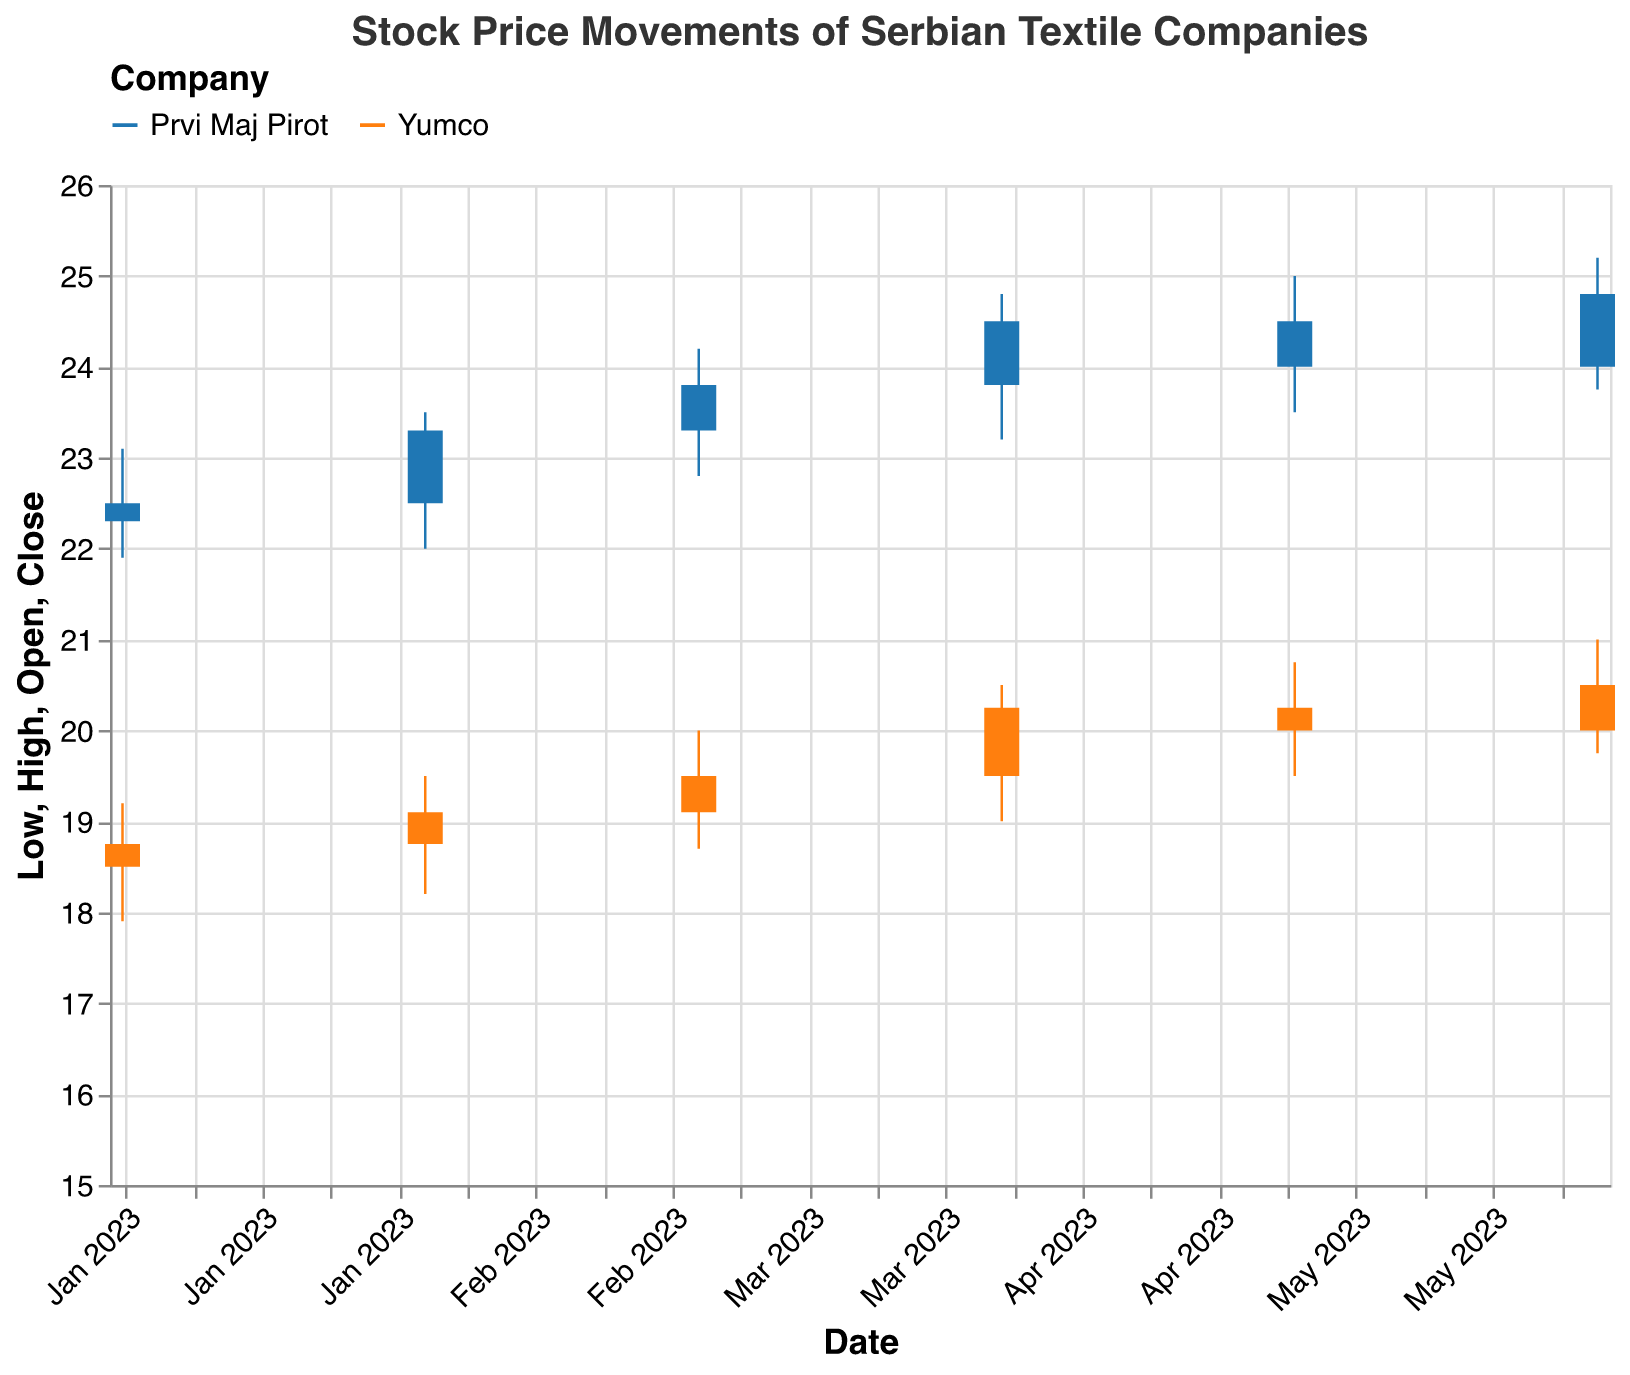What is the title of the plot? The title is usually placed at the top of the figure and gives an overview of what the data represents. Here, the title of the plot is "Stock Price Movements of Serbian Textile Companies".
Answer: Stock Price Movements of Serbian Textile Companies How many data points are there for Yumco? By looking at the x-axis and filtering data visually for the company named "Yumco," we can count the number of distinct dates or candlesticks in the plot. There are 6 data points corresponding to Yumco from January to June 2023.
Answer: 6 Which company had the highest closing price in June 2023? Check the candlestick for June 2023 for both companies. Yumco's closing price is 20.50, and Prvi Maj Pirot's closing price is 24.80. Prvi Maj Pirot has the higher closing price.
Answer: Prvi Maj Pirot What was the lowest price for Prvi Maj Pirot in February 2023? Find the candlestick for Prvi Maj Pirot in February 2023, and look at the "Low" price value, which is represented by the bottom of the candlestick's wick. The lowest price is 22.00.
Answer: 22.00 Which company had more volatility in April 2023? Volatility can be assessed by the difference between the high and low prices. For April 2023, check the high and low prices for both companies: Yumco (High: 20.50, Low: 19.00) and Prvi Maj Pirot (High: 24.80, Low: 23.20). Yumco has higher volatility as it has a difference of 1.50 compared to Prvi Maj Pirot's 1.60.
Answer: Prvi Maj Pirot What was the volume of trades for Yumco in May 2023? Locate the candlestick for May 2023 for Yumco, and refer to the volume value given in the tooltips or the data legend. The volume of trades for Yumco is 15,000.
Answer: 15,000 Which company's stock saw a higher increase from April to May 2023? Calculate the difference in closing prices from April to May for both companies. Yumco: 20.25 (April) to 20.00 (May), a decrease. Prvi Maj Pirot: 24.50 (April) to 24.00 (May), a decrease. Neither company saw an increase.
Answer: Neither What is the average closing price for Yumco from January 2023 to June 2023? Sum the closing prices for Yumco from January to June: 18.75, 19.10, 19.50, 20.25, 20.00, 20.50. The total is 117.10. Divide by the number of months (6). The average closing price is 117.10/6 = 19.52.
Answer: 19.52 Between Prvi Maj Pirot and Yumco, which company had a higher average trading volume in the period shown? First, calculate the average volume of trades for Yumco: (15000+14000+14500+14800+15000+15200)/6 = 14750. Then, calculate for Prvi Maj Pirot: (12000+12500+13000+13500+14000+13800)/6 = 13166.67. Yumco has a higher average trading volume.
Answer: Yumco What was Prvi Maj Pirot's opening price in March 2023? Locate the candlestick for Prvi Maj Pirot in March 2023 and look at the "Open" price value provided, which is the starting value at the top of the body of the candlestick if it is lower than the close. The opening price is 23.30.
Answer: 23.30 